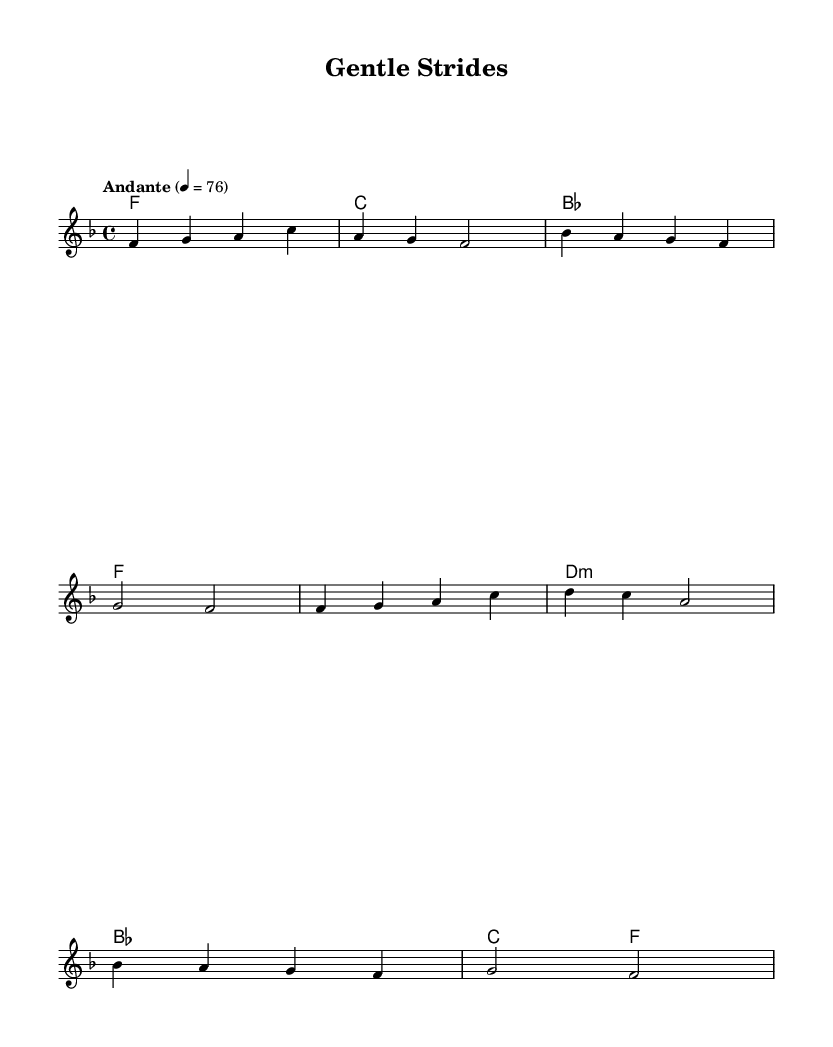What is the key signature of this music? The key signature is F major, which has one flat (B flat). This can be identified by looking at the beginning of the sheet music where the key signature is indicated.
Answer: F major What is the time signature of this music? The time signature is 4/4, which is commonly used in many genres, including K-Pop. This is visible at the beginning of the score, indicating that there are 4 beats in a measure.
Answer: 4/4 What is the tempo marking of this piece? The tempo marking is "Andante," which indicates a moderate walking pace. The specified metronome marking of 76 beats per minute confirms this.
Answer: Andante How many measures does the melody contain? The melody consists of 8 measures, which can be counted by observing the bars in the sheet music. Each group of notes separated by vertical lines represents one measure.
Answer: 8 What type of musical phrases are seen in this piece? The melody contains several short and lyrical phrases that create a calming effect suitable for cool-down. This is typical in K-Pop ballads, where emotional expression is emphasized through melodic phrasing.
Answer: Lyrical phrases Does the piece contain any chord changes? Yes, the piece features chord changes, as indicated in the ChordNames section, showing the harmonic progression throughout the piece. This is common in K-Pop ballads to provide a rich emotional background.
Answer: Yes What emotional vibe does the piece aim to convey? The piece aims to convey a calming and soothing vibe, which is appropriate for post-run cool-down and stretching. This can be inferred from the tempo, key, and lyrical character of the music often found in K-Pop ballads.
Answer: Calming 